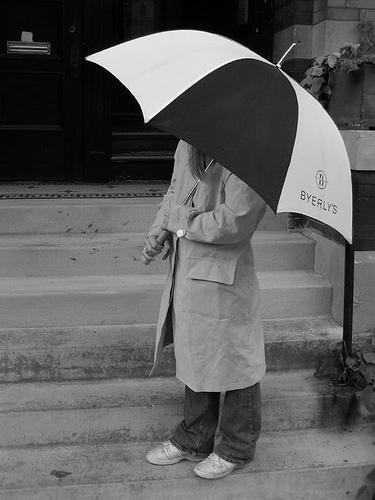What are the steps made out of?
Answer briefly. Concrete. How many steps are there?
Be succinct. 5. What part of this picture is humorous?
Give a very brief answer. Nothing. What is the person wearing?
Be succinct. Raincoat. What is the company that made that umbrella?
Be succinct. Byerly's. Is the door to the building open?
Give a very brief answer. No. Could two people fit under this umbrella?
Short answer required. Yes. 